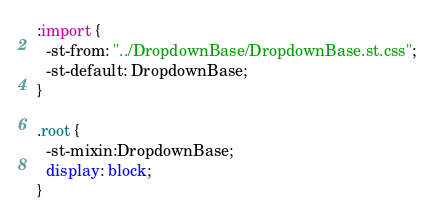Convert code to text. <code><loc_0><loc_0><loc_500><loc_500><_CSS_>:import {
  -st-from: "../DropdownBase/DropdownBase.st.css";
  -st-default: DropdownBase;
}

.root {
  -st-mixin:DropdownBase;
  display: block;
}
</code> 